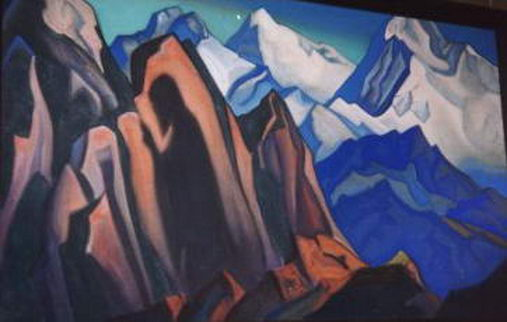Imagine a story inspired by this painting. In a faraway land, nestled between towering mountains and endless skies painted in hues of blue and orange, lived a young explorer named Kael. One day, Kael discovered an ancient map hidden within the rocky terrain, hinting at a forgotten civilization that once flourished in the heart of these mountains. Guided by courage and curiosity, Kael embarked on a journey through the cubist landscape, navigating geometric peaks and valleys, uncovering secrets and unlocking the mystical history of a realm lost in the folds of time. What happens next in Kael's journey? As Kael ventured deeper into the mountains, strange yet mesmerizing structures began to emerge from the terrain. These ancient edifices, carved with intricate geometric patterns, seemed to resonate with the very essence of the cubist landscape around them. Kael felt an odd connection to this hidden world, as if every shape and color whispered forgotten tales. Within one of these structures, Kael discovered a series of crystal fragments, each reflecting a different moment in the civilization's history. Piecing them together, Kael unveiled the truth: the civilization had thrived on the harmonious relationship between nature and art, embedding their legacy into the very mountains themselves. With each step, Kael became more entwined with the vibrancy of this lost culture, eventually realizing that the real treasure was the wisdom and beauty captured within the landscape, waiting to be shared with the world once more. 